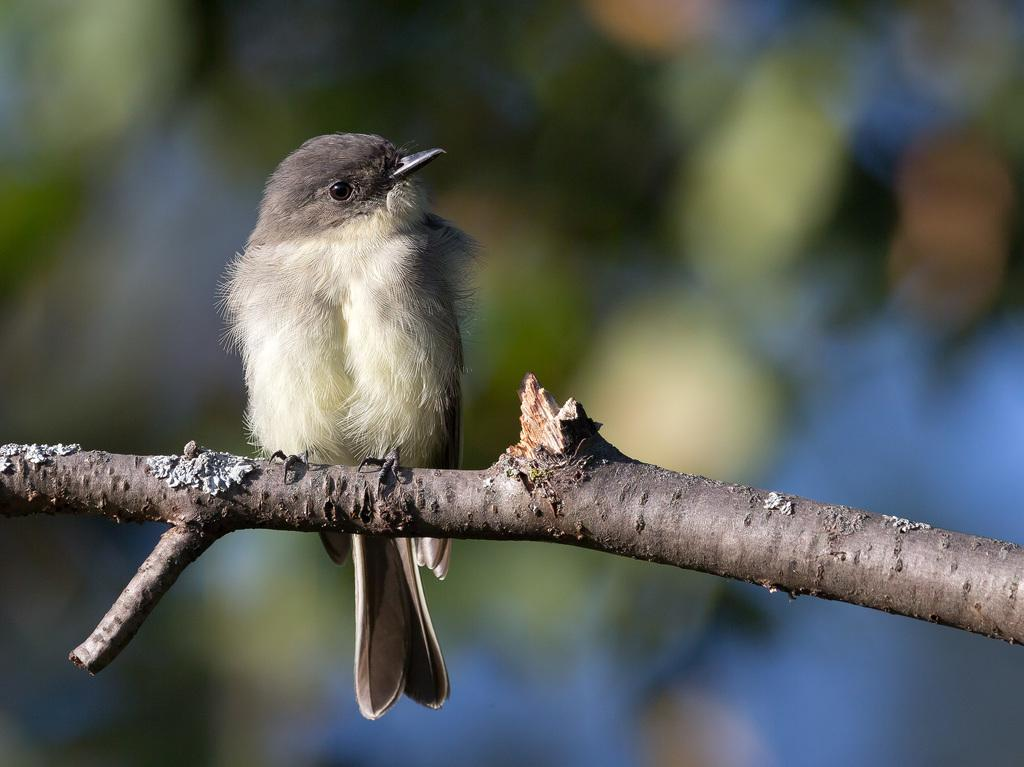What type of animal is present in the image? There is a bird in the image. Where is the bird located in the image? The bird is on a stem. How many ships can be seen sailing in the image? There are no ships present in the image; it features a bird on a stem. What type of balance is the bird demonstrating in the image? The image does not show the bird demonstrating any specific type of balance; it simply shows the bird on a stem. 